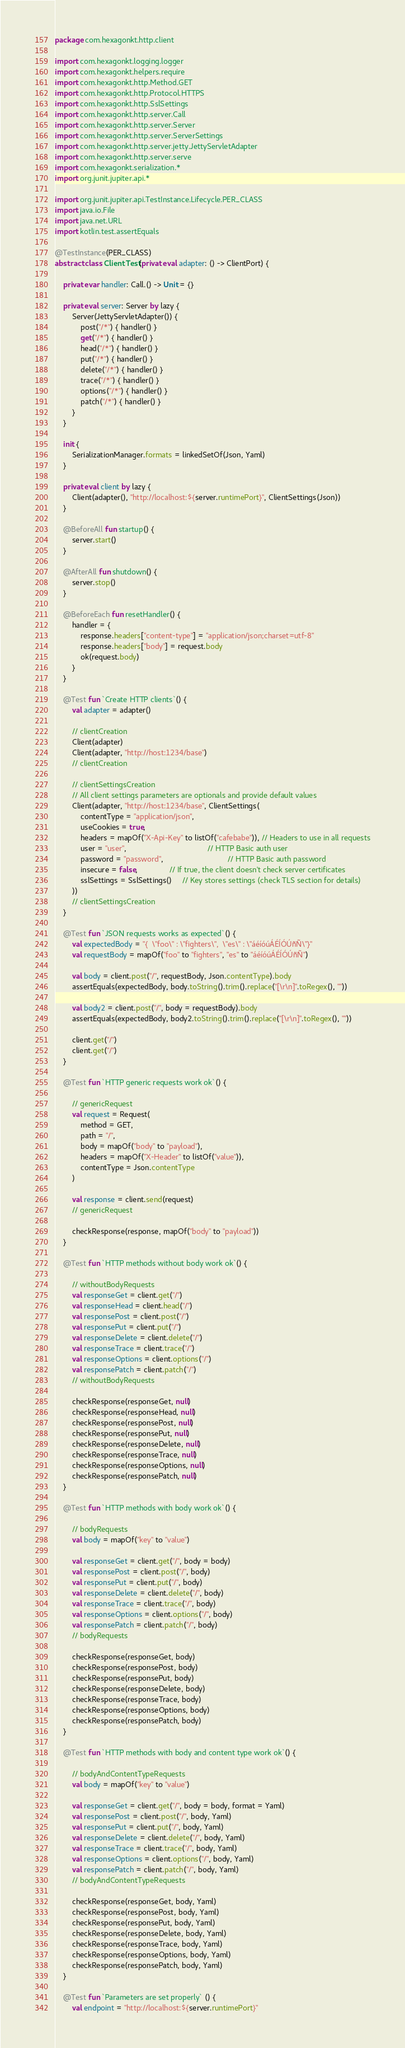<code> <loc_0><loc_0><loc_500><loc_500><_Kotlin_>package com.hexagonkt.http.client

import com.hexagonkt.logging.logger
import com.hexagonkt.helpers.require
import com.hexagonkt.http.Method.GET
import com.hexagonkt.http.Protocol.HTTPS
import com.hexagonkt.http.SslSettings
import com.hexagonkt.http.server.Call
import com.hexagonkt.http.server.Server
import com.hexagonkt.http.server.ServerSettings
import com.hexagonkt.http.server.jetty.JettyServletAdapter
import com.hexagonkt.http.server.serve
import com.hexagonkt.serialization.*
import org.junit.jupiter.api.*

import org.junit.jupiter.api.TestInstance.Lifecycle.PER_CLASS
import java.io.File
import java.net.URL
import kotlin.test.assertEquals

@TestInstance(PER_CLASS)
abstract class ClientTest(private val adapter: () -> ClientPort) {

    private var handler: Call.() -> Unit = {}

    private val server: Server by lazy {
        Server(JettyServletAdapter()) {
            post("/*") { handler() }
            get("/*") { handler() }
            head("/*") { handler() }
            put("/*") { handler() }
            delete("/*") { handler() }
            trace("/*") { handler() }
            options("/*") { handler() }
            patch("/*") { handler() }
        }
    }

    init {
        SerializationManager.formats = linkedSetOf(Json, Yaml)
    }

    private val client by lazy {
        Client(adapter(), "http://localhost:${server.runtimePort}", ClientSettings(Json))
    }

    @BeforeAll fun startup() {
        server.start()
    }

    @AfterAll fun shutdown() {
        server.stop()
    }

    @BeforeEach fun resetHandler() {
        handler = {
            response.headers["content-type"] = "application/json;charset=utf-8"
            response.headers["body"] = request.body
            ok(request.body)
        }
    }

    @Test fun `Create HTTP clients`() {
        val adapter = adapter()

        // clientCreation
        Client(adapter)
        Client(adapter, "http://host:1234/base")
        // clientCreation

        // clientSettingsCreation
        // All client settings parameters are optionals and provide default values
        Client(adapter, "http://host:1234/base", ClientSettings(
            contentType = "application/json",
            useCookies = true,
            headers = mapOf("X-Api-Key" to listOf("cafebabe")), // Headers to use in all requests
            user = "user",                                      // HTTP Basic auth user
            password = "password",                              // HTTP Basic auth password
            insecure = false,               // If true, the client doesn't check server certificates
            sslSettings = SslSettings()     // Key stores settings (check TLS section for details)
        ))
        // clientSettingsCreation
    }

    @Test fun `JSON requests works as expected`() {
        val expectedBody = "{  \"foo\" : \"fighters\",  \"es\" : \"áéíóúÁÉÍÓÚñÑ\"}"
        val requestBody = mapOf("foo" to "fighters", "es" to "áéíóúÁÉÍÓÚñÑ")

        val body = client.post("/", requestBody, Json.contentType).body
        assertEquals(expectedBody, body.toString().trim().replace("[\r\n]".toRegex(), ""))

        val body2 = client.post("/", body = requestBody).body
        assertEquals(expectedBody, body2.toString().trim().replace("[\r\n]".toRegex(), ""))

        client.get("/")
        client.get("/")
    }

    @Test fun `HTTP generic requests work ok`() {

        // genericRequest
        val request = Request(
            method = GET,
            path = "/",
            body = mapOf("body" to "payload"),
            headers = mapOf("X-Header" to listOf("value")),
            contentType = Json.contentType
        )

        val response = client.send(request)
        // genericRequest

        checkResponse(response, mapOf("body" to "payload"))
    }

    @Test fun `HTTP methods without body work ok`() {

        // withoutBodyRequests
        val responseGet = client.get("/")
        val responseHead = client.head("/")
        val responsePost = client.post("/")
        val responsePut = client.put("/")
        val responseDelete = client.delete("/")
        val responseTrace = client.trace("/")
        val responseOptions = client.options("/")
        val responsePatch = client.patch("/")
        // withoutBodyRequests

        checkResponse(responseGet, null)
        checkResponse(responseHead, null)
        checkResponse(responsePost, null)
        checkResponse(responsePut, null)
        checkResponse(responseDelete, null)
        checkResponse(responseTrace, null)
        checkResponse(responseOptions, null)
        checkResponse(responsePatch, null)
    }

    @Test fun `HTTP methods with body work ok`() {

        // bodyRequests
        val body = mapOf("key" to "value")

        val responseGet = client.get("/", body = body)
        val responsePost = client.post("/", body)
        val responsePut = client.put("/", body)
        val responseDelete = client.delete("/", body)
        val responseTrace = client.trace("/", body)
        val responseOptions = client.options("/", body)
        val responsePatch = client.patch("/", body)
        // bodyRequests

        checkResponse(responseGet, body)
        checkResponse(responsePost, body)
        checkResponse(responsePut, body)
        checkResponse(responseDelete, body)
        checkResponse(responseTrace, body)
        checkResponse(responseOptions, body)
        checkResponse(responsePatch, body)
    }

    @Test fun `HTTP methods with body and content type work ok`() {

        // bodyAndContentTypeRequests
        val body = mapOf("key" to "value")

        val responseGet = client.get("/", body = body, format = Yaml)
        val responsePost = client.post("/", body, Yaml)
        val responsePut = client.put("/", body, Yaml)
        val responseDelete = client.delete("/", body, Yaml)
        val responseTrace = client.trace("/", body, Yaml)
        val responseOptions = client.options("/", body, Yaml)
        val responsePatch = client.patch("/", body, Yaml)
        // bodyAndContentTypeRequests

        checkResponse(responseGet, body, Yaml)
        checkResponse(responsePost, body, Yaml)
        checkResponse(responsePut, body, Yaml)
        checkResponse(responseDelete, body, Yaml)
        checkResponse(responseTrace, body, Yaml)
        checkResponse(responseOptions, body, Yaml)
        checkResponse(responsePatch, body, Yaml)
    }

    @Test fun `Parameters are set properly` () {
        val endpoint = "http://localhost:${server.runtimePort}"</code> 